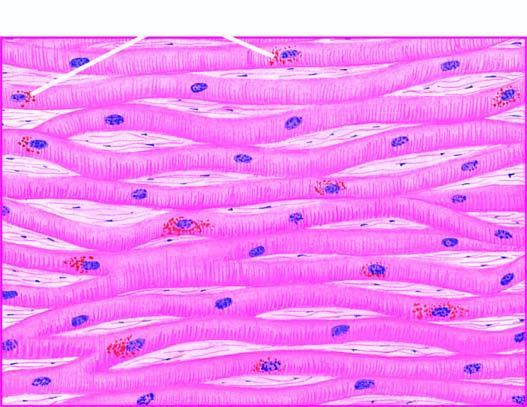what are the lipofuscin pigment granules seen in?
Answer the question using a single word or phrase. Cytoplasm myocardial fibres 